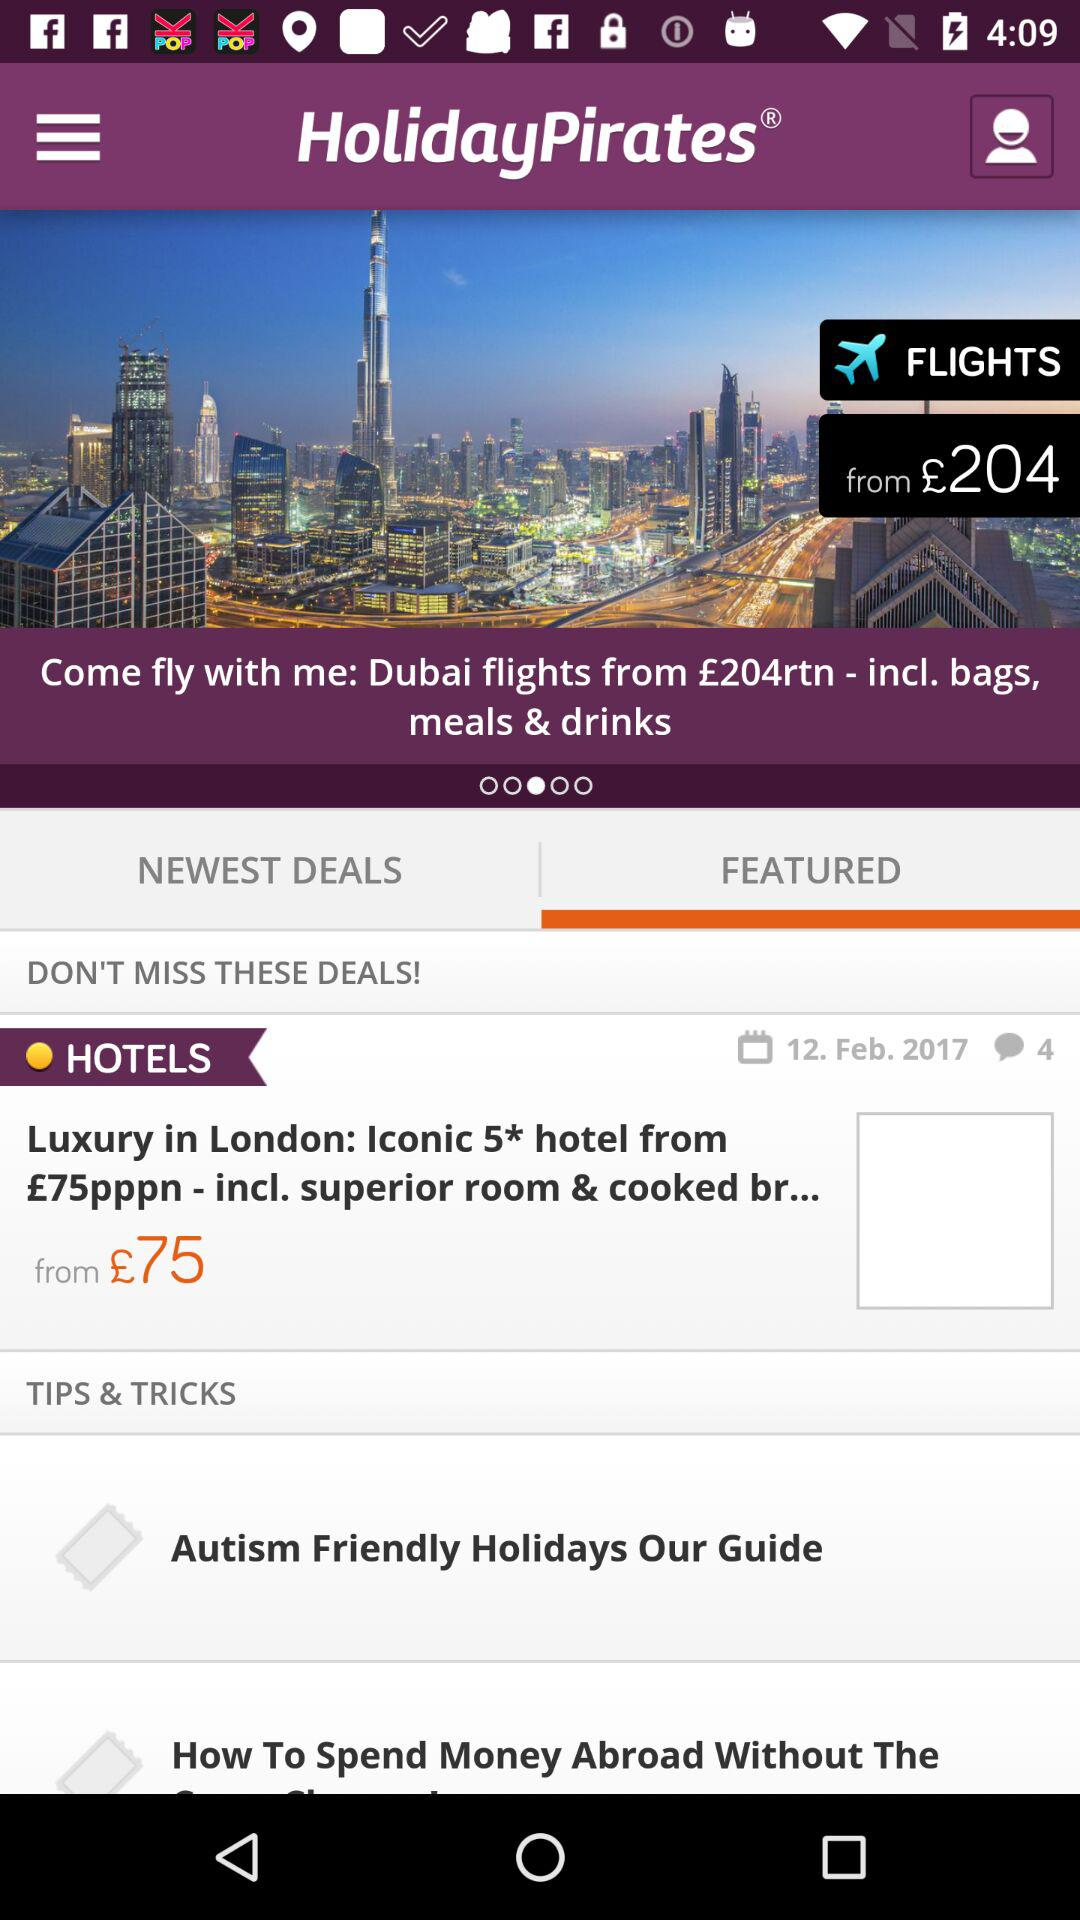What is the name of the application? The name of the application is "HolidayPirates". 